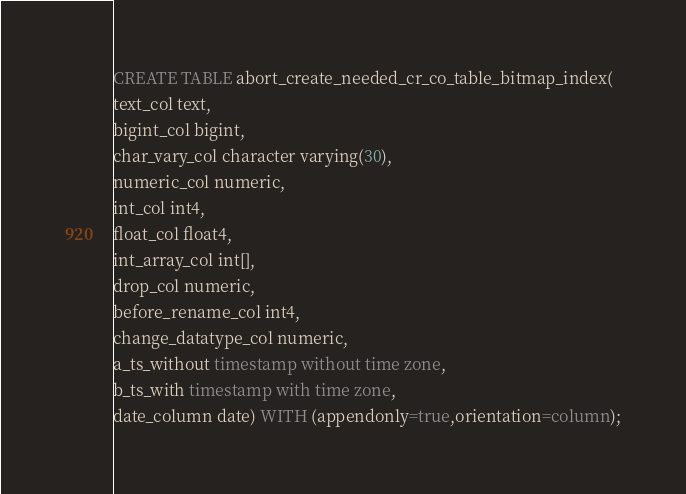Convert code to text. <code><loc_0><loc_0><loc_500><loc_500><_SQL_>CREATE TABLE abort_create_needed_cr_co_table_bitmap_index(
text_col text,
bigint_col bigint,
char_vary_col character varying(30),
numeric_col numeric,
int_col int4,
float_col float4,
int_array_col int[],
drop_col numeric,
before_rename_col int4,
change_datatype_col numeric,
a_ts_without timestamp without time zone,
b_ts_with timestamp with time zone,
date_column date) WITH (appendonly=true,orientation=column);
</code> 